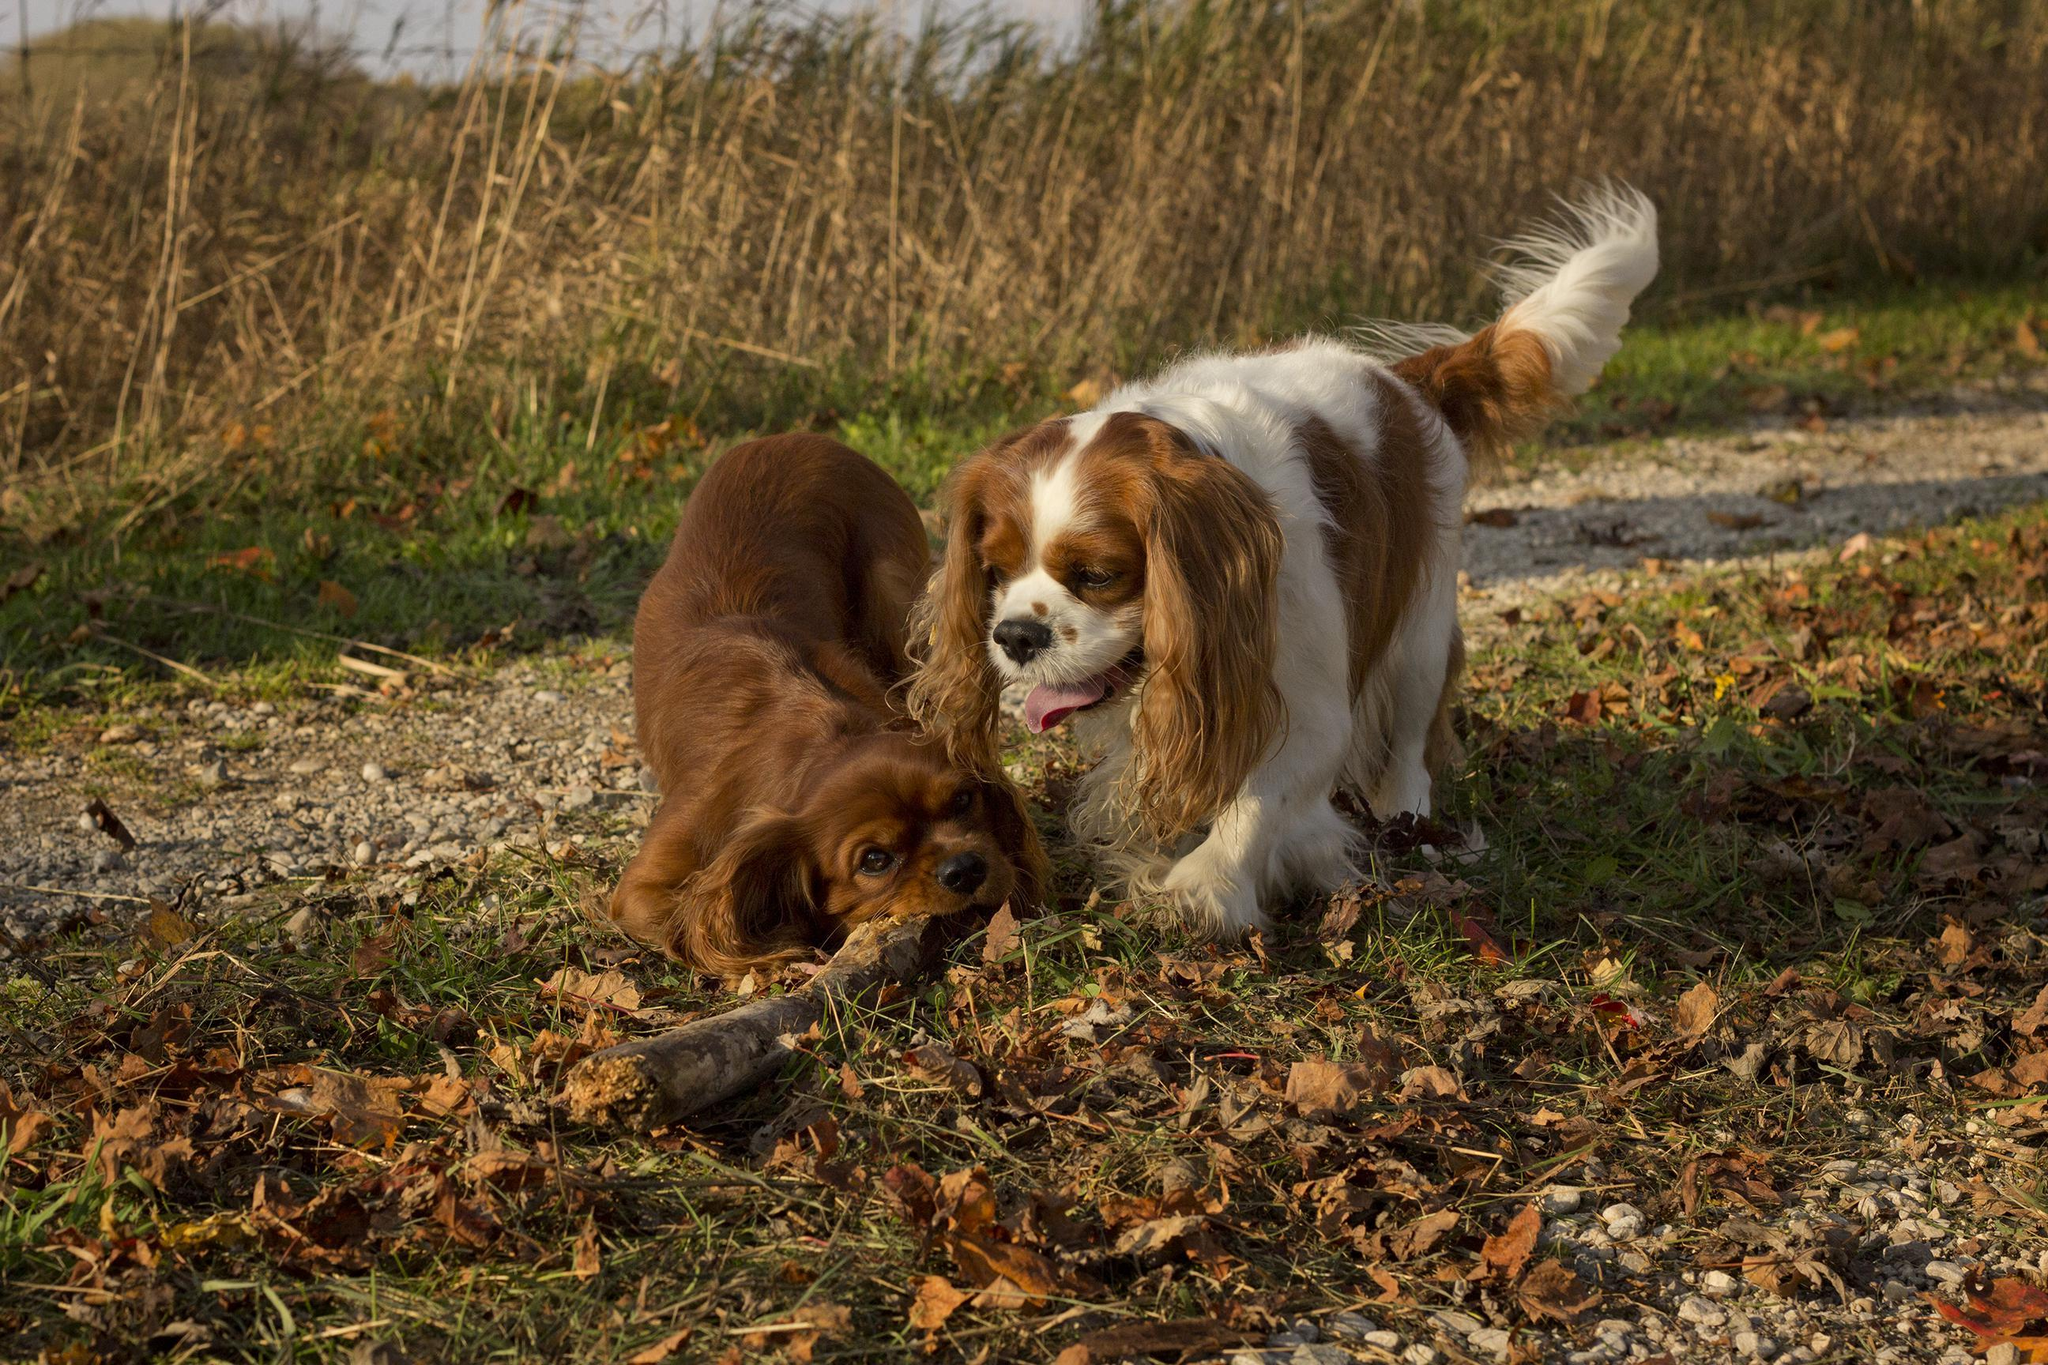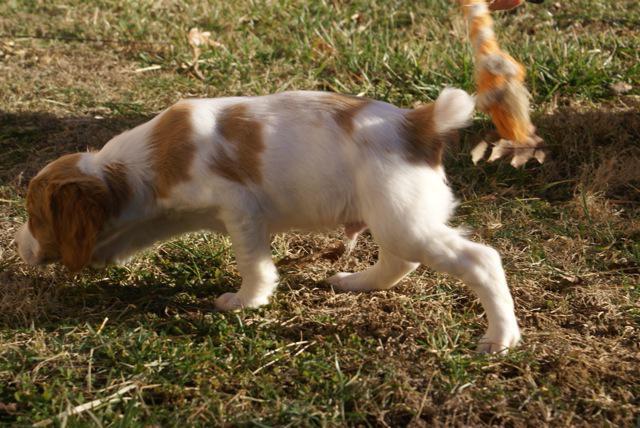The first image is the image on the left, the second image is the image on the right. Examine the images to the left and right. Is the description "An orange spaniel is on the right of an orange-and-white spaniel, and they are face-to-face on the grass." accurate? Answer yes or no. No. The first image is the image on the left, the second image is the image on the right. Examine the images to the left and right. Is the description "In one image, a brown dog appears to try and kiss a brown and white dog under its chin" accurate? Answer yes or no. No. 